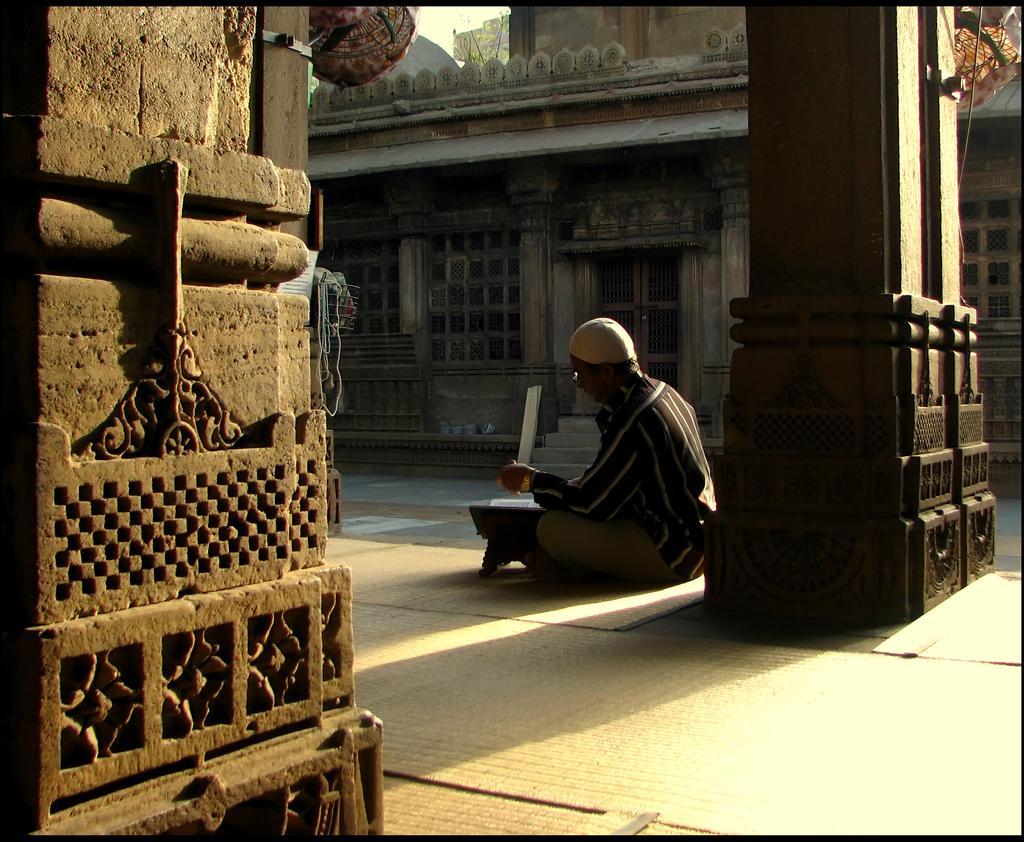In one or two sentences, can you explain what this image depicts? This is the picture of a place where we have a house, pillar and a person sitting in front of the pillar and also we can see a table. 